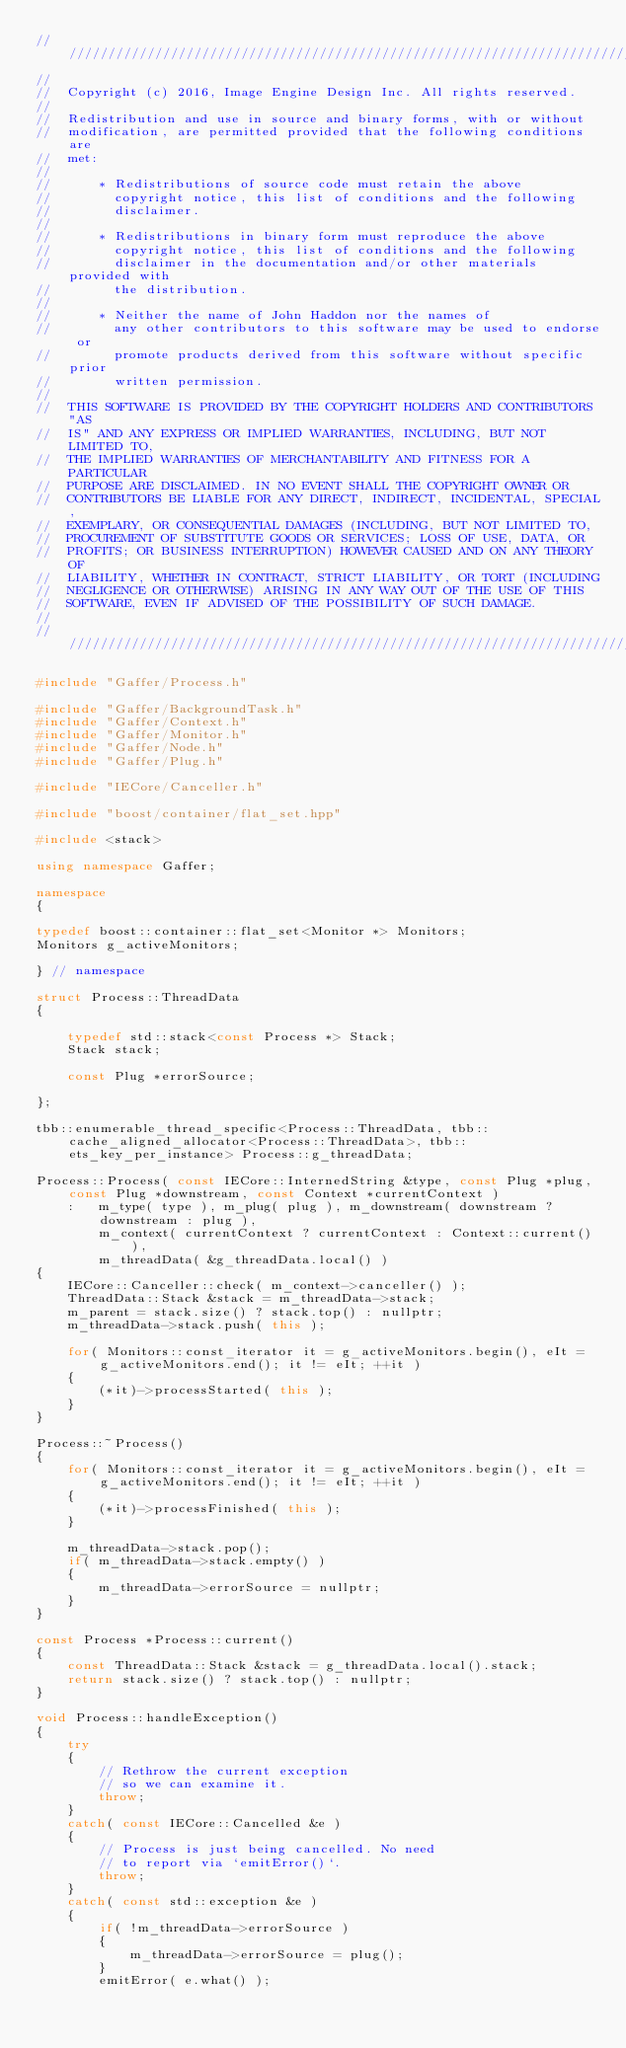<code> <loc_0><loc_0><loc_500><loc_500><_C++_>//////////////////////////////////////////////////////////////////////////
//
//  Copyright (c) 2016, Image Engine Design Inc. All rights reserved.
//
//  Redistribution and use in source and binary forms, with or without
//  modification, are permitted provided that the following conditions are
//  met:
//
//      * Redistributions of source code must retain the above
//        copyright notice, this list of conditions and the following
//        disclaimer.
//
//      * Redistributions in binary form must reproduce the above
//        copyright notice, this list of conditions and the following
//        disclaimer in the documentation and/or other materials provided with
//        the distribution.
//
//      * Neither the name of John Haddon nor the names of
//        any other contributors to this software may be used to endorse or
//        promote products derived from this software without specific prior
//        written permission.
//
//  THIS SOFTWARE IS PROVIDED BY THE COPYRIGHT HOLDERS AND CONTRIBUTORS "AS
//  IS" AND ANY EXPRESS OR IMPLIED WARRANTIES, INCLUDING, BUT NOT LIMITED TO,
//  THE IMPLIED WARRANTIES OF MERCHANTABILITY AND FITNESS FOR A PARTICULAR
//  PURPOSE ARE DISCLAIMED. IN NO EVENT SHALL THE COPYRIGHT OWNER OR
//  CONTRIBUTORS BE LIABLE FOR ANY DIRECT, INDIRECT, INCIDENTAL, SPECIAL,
//  EXEMPLARY, OR CONSEQUENTIAL DAMAGES (INCLUDING, BUT NOT LIMITED TO,
//  PROCUREMENT OF SUBSTITUTE GOODS OR SERVICES; LOSS OF USE, DATA, OR
//  PROFITS; OR BUSINESS INTERRUPTION) HOWEVER CAUSED AND ON ANY THEORY OF
//  LIABILITY, WHETHER IN CONTRACT, STRICT LIABILITY, OR TORT (INCLUDING
//  NEGLIGENCE OR OTHERWISE) ARISING IN ANY WAY OUT OF THE USE OF THIS
//  SOFTWARE, EVEN IF ADVISED OF THE POSSIBILITY OF SUCH DAMAGE.
//
//////////////////////////////////////////////////////////////////////////

#include "Gaffer/Process.h"

#include "Gaffer/BackgroundTask.h"
#include "Gaffer/Context.h"
#include "Gaffer/Monitor.h"
#include "Gaffer/Node.h"
#include "Gaffer/Plug.h"

#include "IECore/Canceller.h"

#include "boost/container/flat_set.hpp"

#include <stack>

using namespace Gaffer;

namespace
{

typedef boost::container::flat_set<Monitor *> Monitors;
Monitors g_activeMonitors;

} // namespace

struct Process::ThreadData
{

	typedef std::stack<const Process *> Stack;
	Stack stack;

	const Plug *errorSource;

};

tbb::enumerable_thread_specific<Process::ThreadData, tbb::cache_aligned_allocator<Process::ThreadData>, tbb::ets_key_per_instance> Process::g_threadData;

Process::Process( const IECore::InternedString &type, const Plug *plug, const Plug *downstream, const Context *currentContext )
	:	m_type( type ), m_plug( plug ), m_downstream( downstream ? downstream : plug ),
		m_context( currentContext ? currentContext : Context::current() ),
		m_threadData( &g_threadData.local() )
{
	IECore::Canceller::check( m_context->canceller() );
	ThreadData::Stack &stack = m_threadData->stack;
	m_parent = stack.size() ? stack.top() : nullptr;
	m_threadData->stack.push( this );

	for( Monitors::const_iterator it = g_activeMonitors.begin(), eIt = g_activeMonitors.end(); it != eIt; ++it )
	{
		(*it)->processStarted( this );
	}
}

Process::~Process()
{
	for( Monitors::const_iterator it = g_activeMonitors.begin(), eIt = g_activeMonitors.end(); it != eIt; ++it )
	{
		(*it)->processFinished( this );
	}

	m_threadData->stack.pop();
	if( m_threadData->stack.empty() )
	{
		m_threadData->errorSource = nullptr;
	}
}

const Process *Process::current()
{
	const ThreadData::Stack &stack = g_threadData.local().stack;
	return stack.size() ? stack.top() : nullptr;
}

void Process::handleException()
{
	try
	{
		// Rethrow the current exception
		// so we can examine it.
		throw;
	}
	catch( const IECore::Cancelled &e )
	{
		// Process is just being cancelled. No need
		// to report via `emitError()`.
		throw;
	}
	catch( const std::exception &e )
	{
		if( !m_threadData->errorSource )
		{
			m_threadData->errorSource = plug();
		}
		emitError( e.what() );</code> 